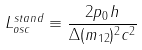<formula> <loc_0><loc_0><loc_500><loc_500>L _ { o s c } ^ { s t a n d } \equiv \frac { 2 p _ { 0 } h } { \Delta ( m _ { 1 2 } ) ^ { 2 } c ^ { 2 } }</formula> 